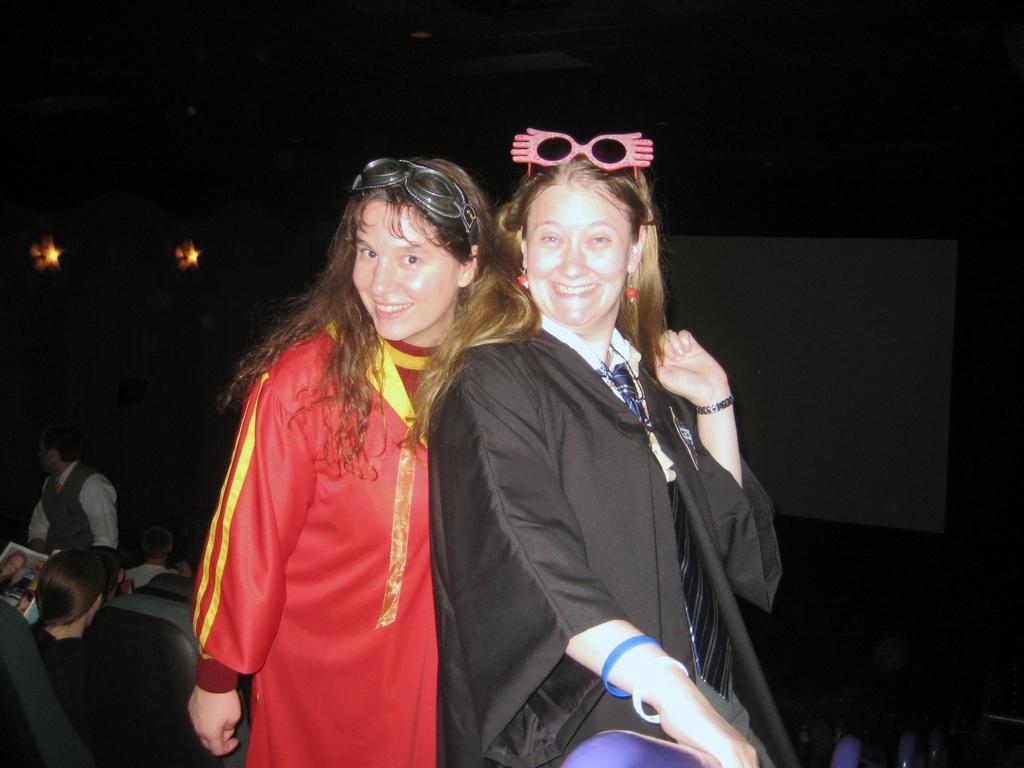In one or two sentences, can you explain what this image depicts? On the left side, there is a woman in red color coat, smiling and standing. Beside her, there is another woman in black color coat, smiling and standing. In the background, there are other persons and there are lights. And the background is dark in color. 